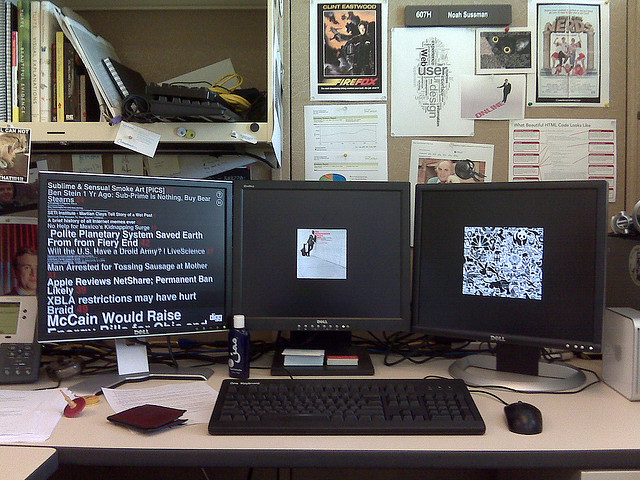Please identify all text content in this image. user Would End design may NERDS ONLINE Steams BUY Nothing Sub Ago Stein Ben Art Sensual the Will U.S. Army Live Man For Arrested Mother Sausage Tossing NetShare Reviews Apple Likely Braid McCain Raise XBLA restrictions have hurt Ban Permanent Flery from From Earth Saved System Planetary POLITE HOT firefox Web EASTWOOD 